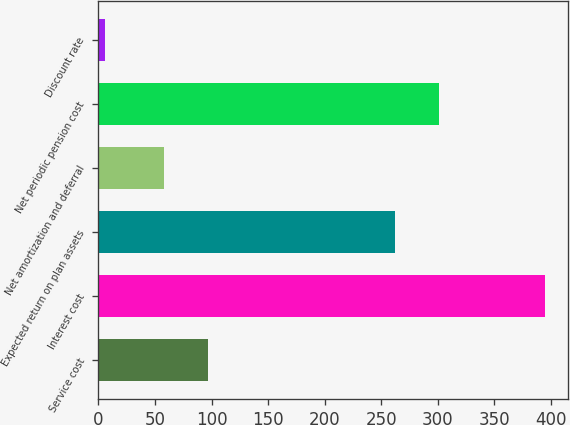Convert chart to OTSL. <chart><loc_0><loc_0><loc_500><loc_500><bar_chart><fcel>Service cost<fcel>Interest cost<fcel>Expected return on plan assets<fcel>Net amortization and deferral<fcel>Net periodic pension cost<fcel>Discount rate<nl><fcel>96.95<fcel>395<fcel>262<fcel>58<fcel>300.95<fcel>5.5<nl></chart> 